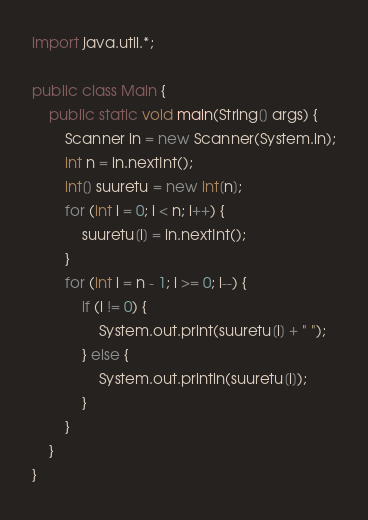Convert code to text. <code><loc_0><loc_0><loc_500><loc_500><_Java_>import java.util.*;

public class Main {
	public static void main(String[] args) {
		Scanner in = new Scanner(System.in);
		int n = in.nextInt();
		int[] suuretu = new int[n];
		for (int i = 0; i < n; i++) {
			suuretu[i] = in.nextInt();
		}
		for (int i = n - 1; i >= 0; i--) {
			if (i != 0) {
				System.out.print(suuretu[i] + " ");
			} else {
				System.out.println(suuretu[i]);
			}
		}
	}
}</code> 